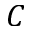Convert formula to latex. <formula><loc_0><loc_0><loc_500><loc_500>C</formula> 